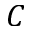Convert formula to latex. <formula><loc_0><loc_0><loc_500><loc_500>C</formula> 